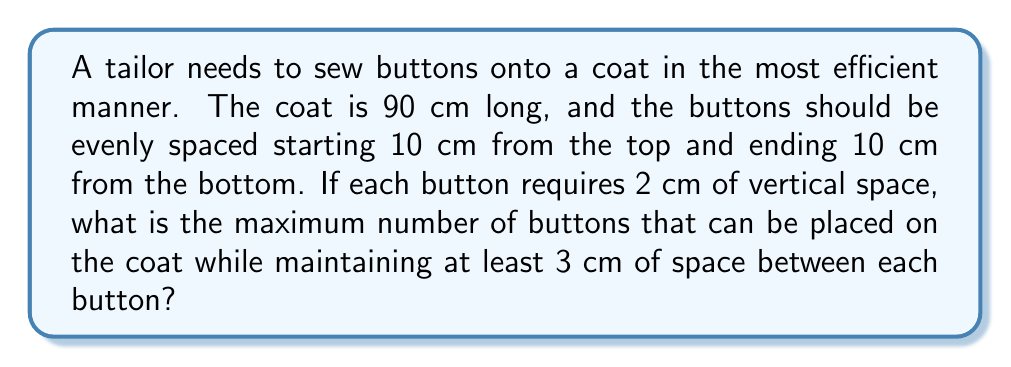Solve this math problem. Let's approach this step-by-step:

1) First, calculate the available space for buttons:
   Total coat length = 90 cm
   Space at top and bottom = 10 cm + 10 cm = 20 cm
   Available space = 90 cm - 20 cm = 70 cm

2) Let $n$ be the number of buttons. We need to fit:
   - $n$ buttons, each 2 cm tall
   - $(n-1)$ spaces between buttons, each at least 3 cm tall

3) We can express this as an inequality:
   $$ 2n + 3(n-1) \leq 70 $$

4) Simplify the left side of the inequality:
   $$ 2n + 3n - 3 \leq 70 $$
   $$ 5n - 3 \leq 70 $$

5) Solve for $n$:
   $$ 5n \leq 73 $$
   $$ n \leq 14.6 $$

6) Since $n$ must be a whole number, and we're looking for the maximum, we round down to 14.

7) Verify:
   14 buttons: 14 * 2 cm = 28 cm
   13 spaces: 13 * 3 cm = 39 cm
   Total: 28 cm + 39 cm = 67 cm < 70 cm (available space)

Therefore, the maximum number of buttons is 14.
Answer: 14 buttons 